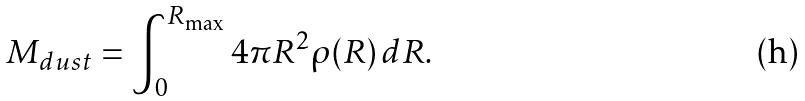<formula> <loc_0><loc_0><loc_500><loc_500>M _ { d u s t } = \int ^ { R _ { \max } } _ { 0 } { 4 \pi R ^ { 2 } \rho ( R ) \, d R } .</formula> 